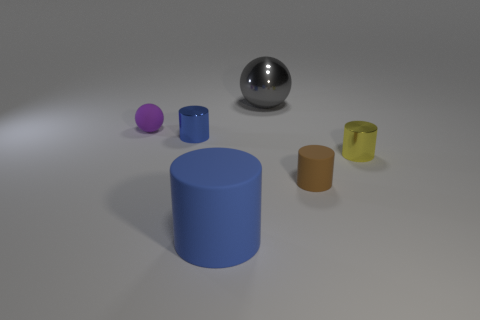What shapes are present in this image? The image contains a variety of geometric shapes: there's a sphere, several cylinders of different sizes and colors, and what appears to be a hemisphere or a partially visible sphere. 